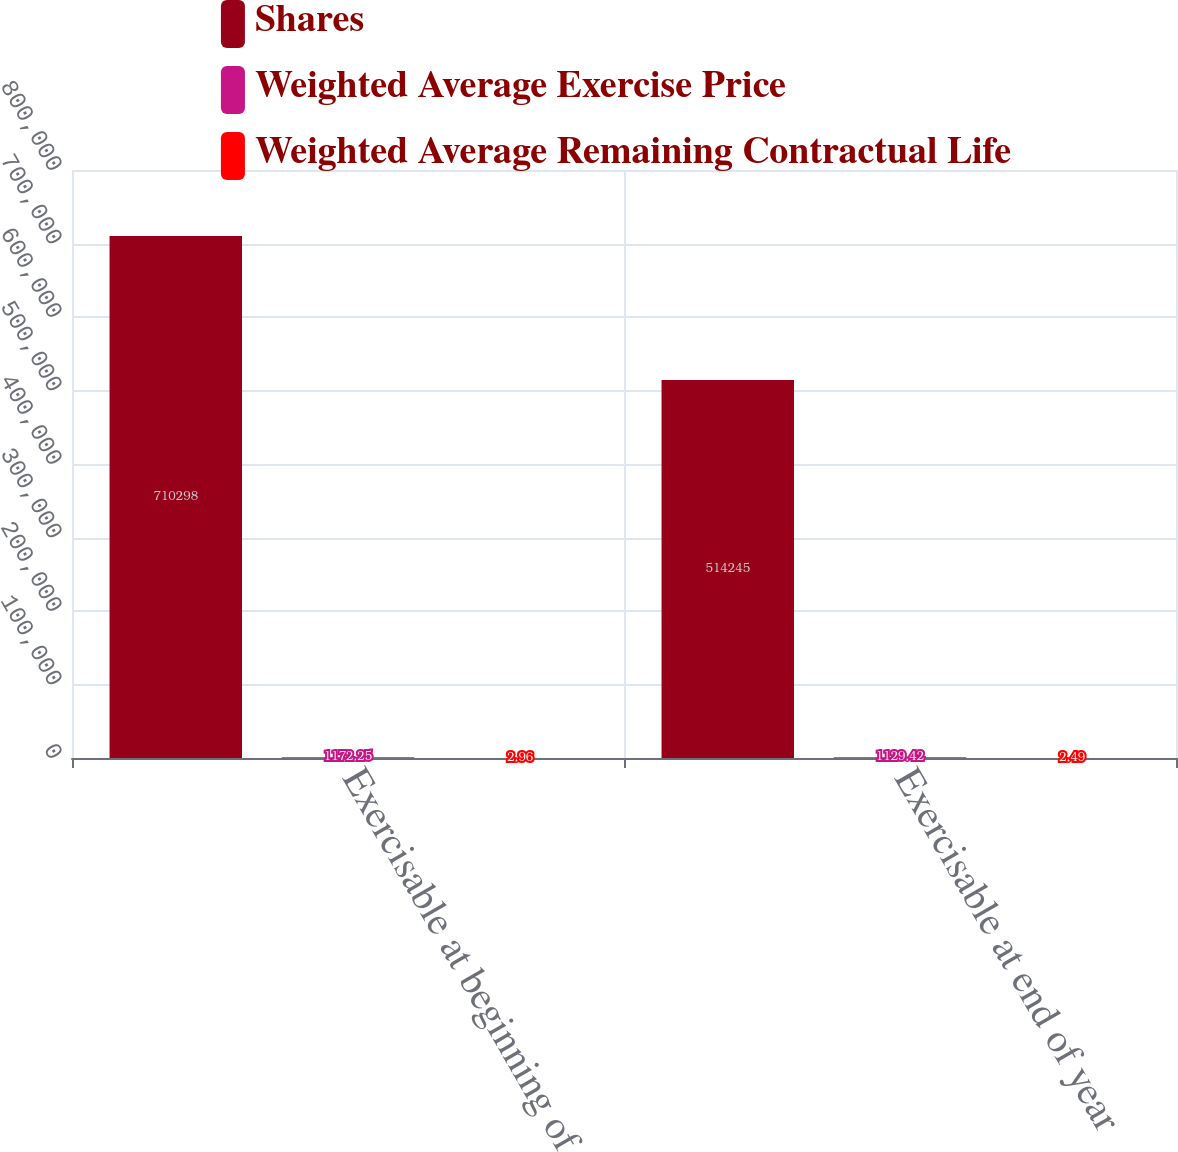Convert chart. <chart><loc_0><loc_0><loc_500><loc_500><stacked_bar_chart><ecel><fcel>Exercisable at beginning of<fcel>Exercisable at end of year<nl><fcel>Shares<fcel>710298<fcel>514245<nl><fcel>Weighted Average Exercise Price<fcel>1172.25<fcel>1129.42<nl><fcel>Weighted Average Remaining Contractual Life<fcel>2.96<fcel>2.49<nl></chart> 